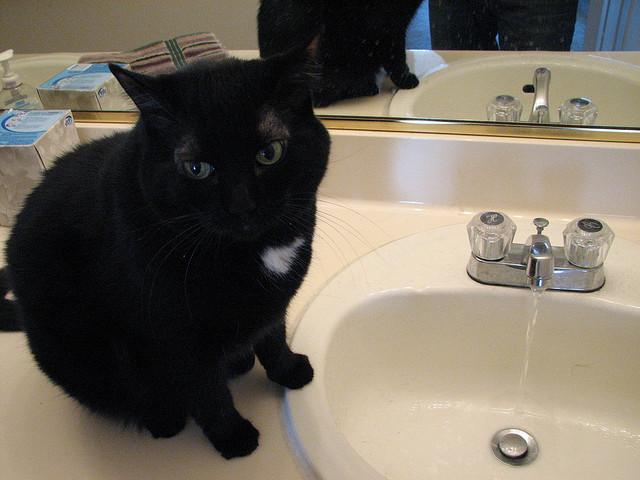What color are the cat's eyebrows?
Write a very short answer. Brown. Is the water on?
Answer briefly. Yes. Did the cat do something wrong?
Keep it brief. No. 